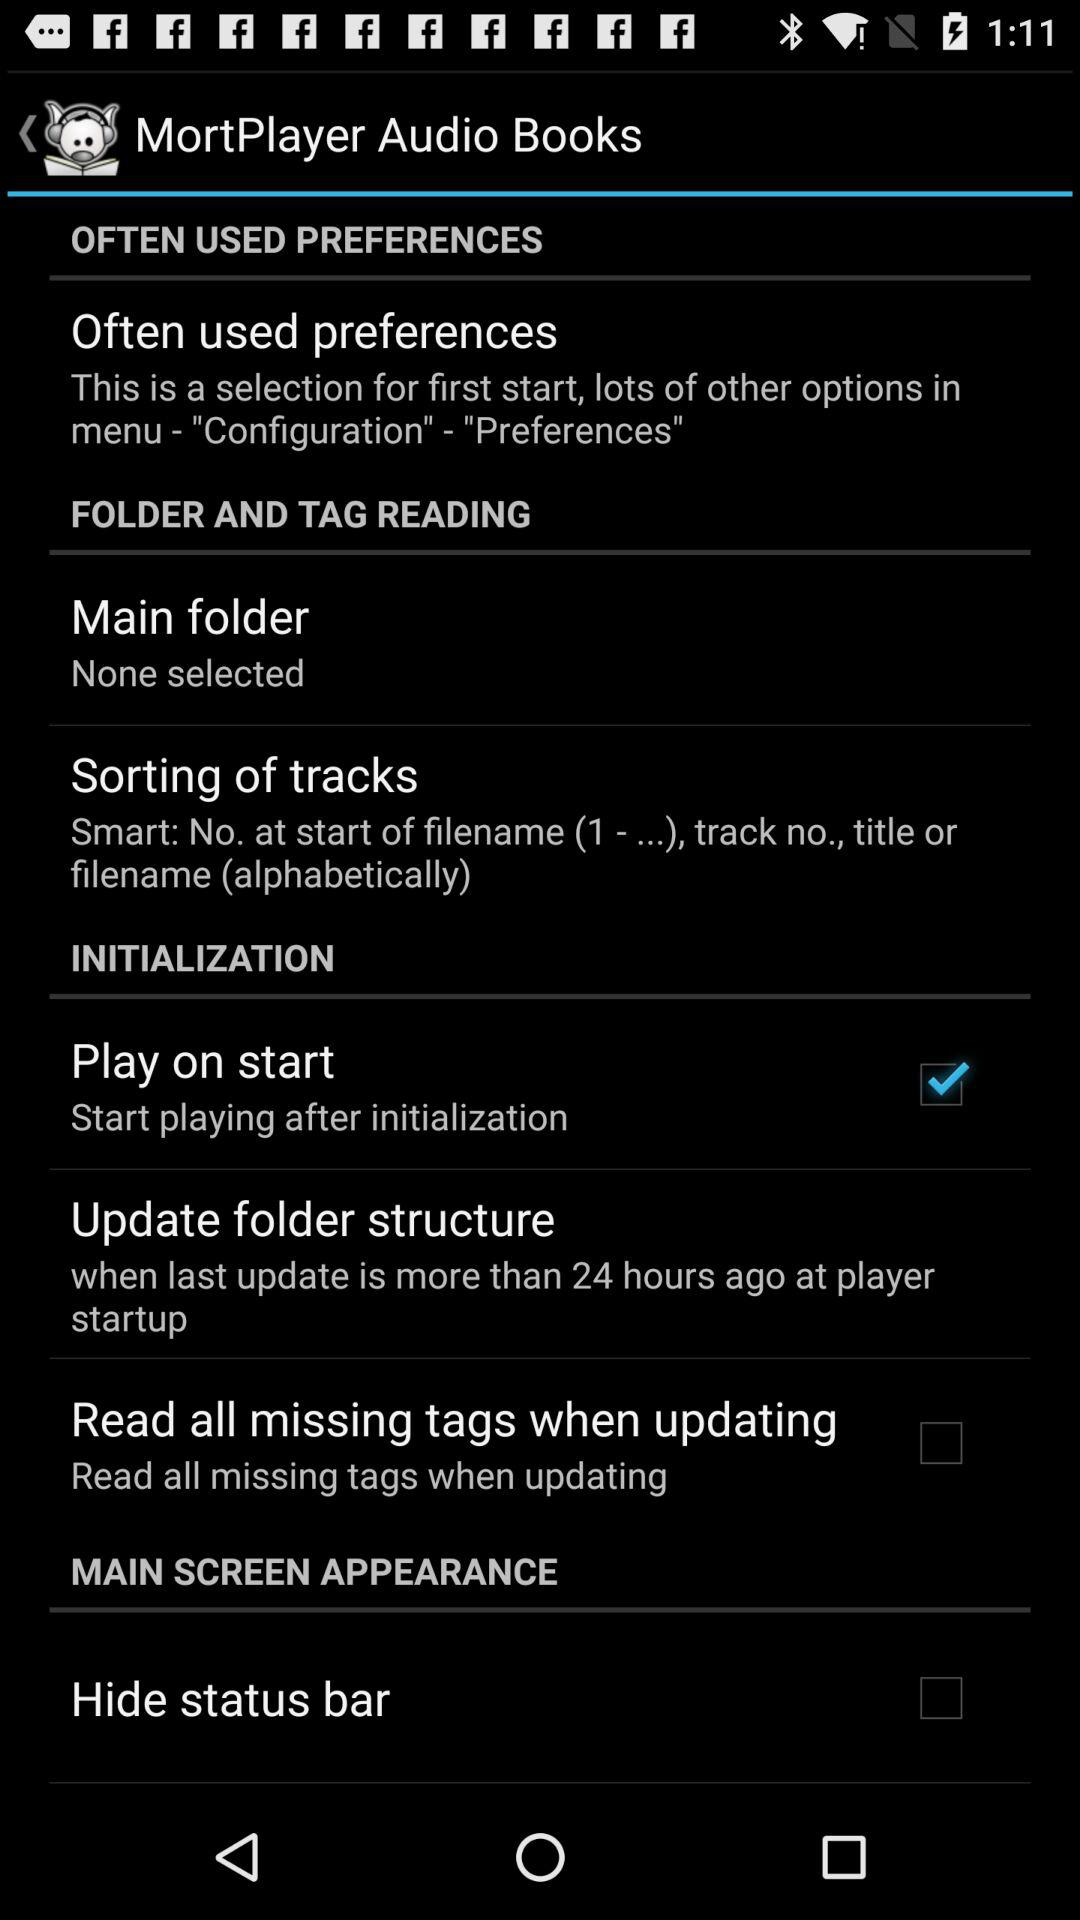Is "Play on start" on? "Play on start" is on. 